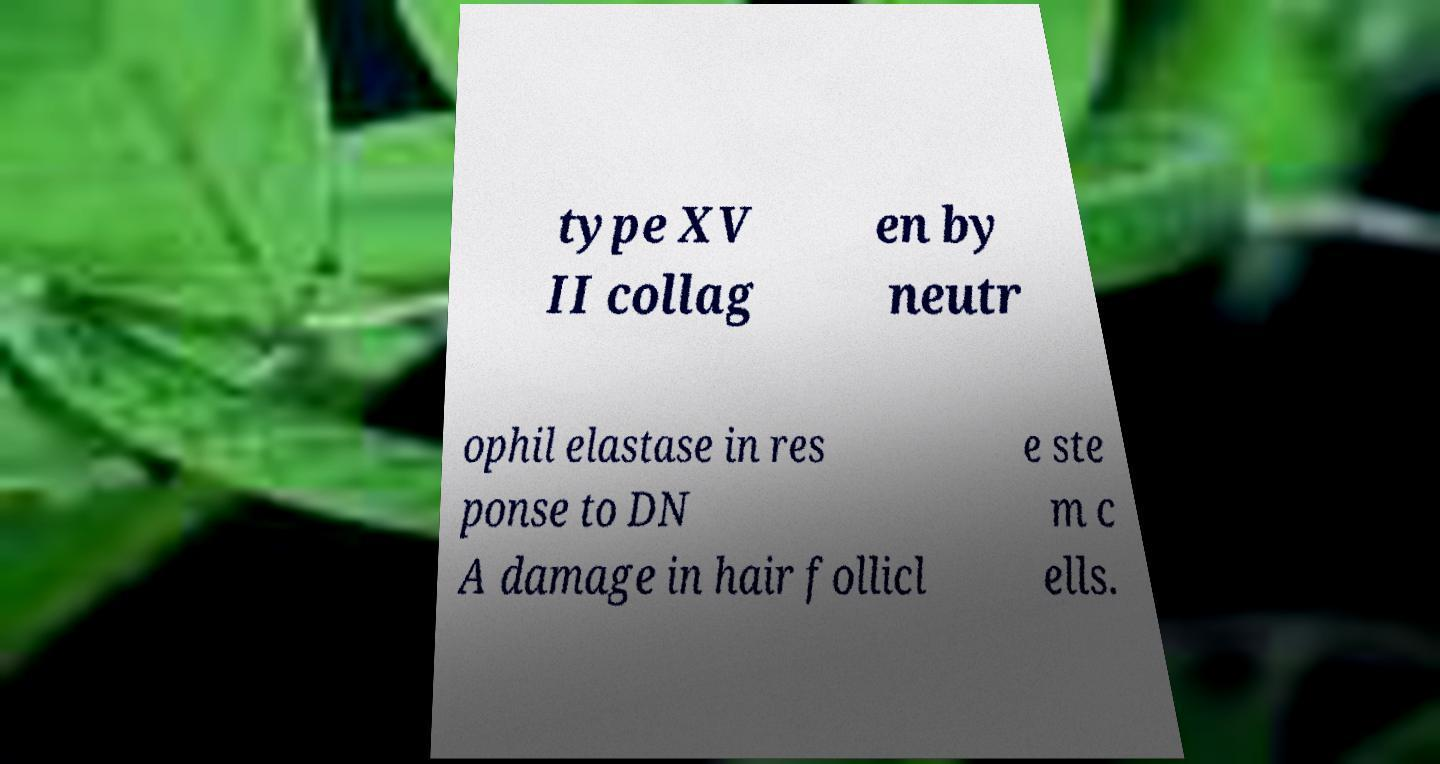Could you assist in decoding the text presented in this image and type it out clearly? type XV II collag en by neutr ophil elastase in res ponse to DN A damage in hair follicl e ste m c ells. 